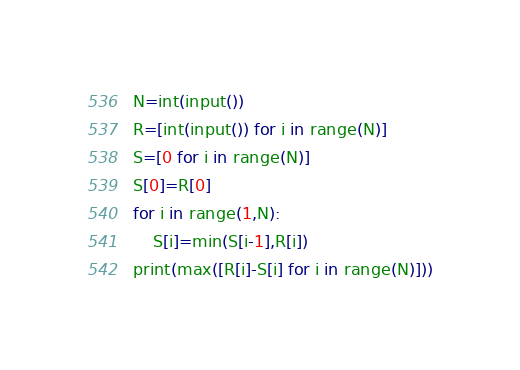<code> <loc_0><loc_0><loc_500><loc_500><_Python_>N=int(input())
R=[int(input()) for i in range(N)]
S=[0 for i in range(N)]
S[0]=R[0]
for i in range(1,N):
    S[i]=min(S[i-1],R[i])
print(max([R[i]-S[i] for i in range(N)]))

</code> 